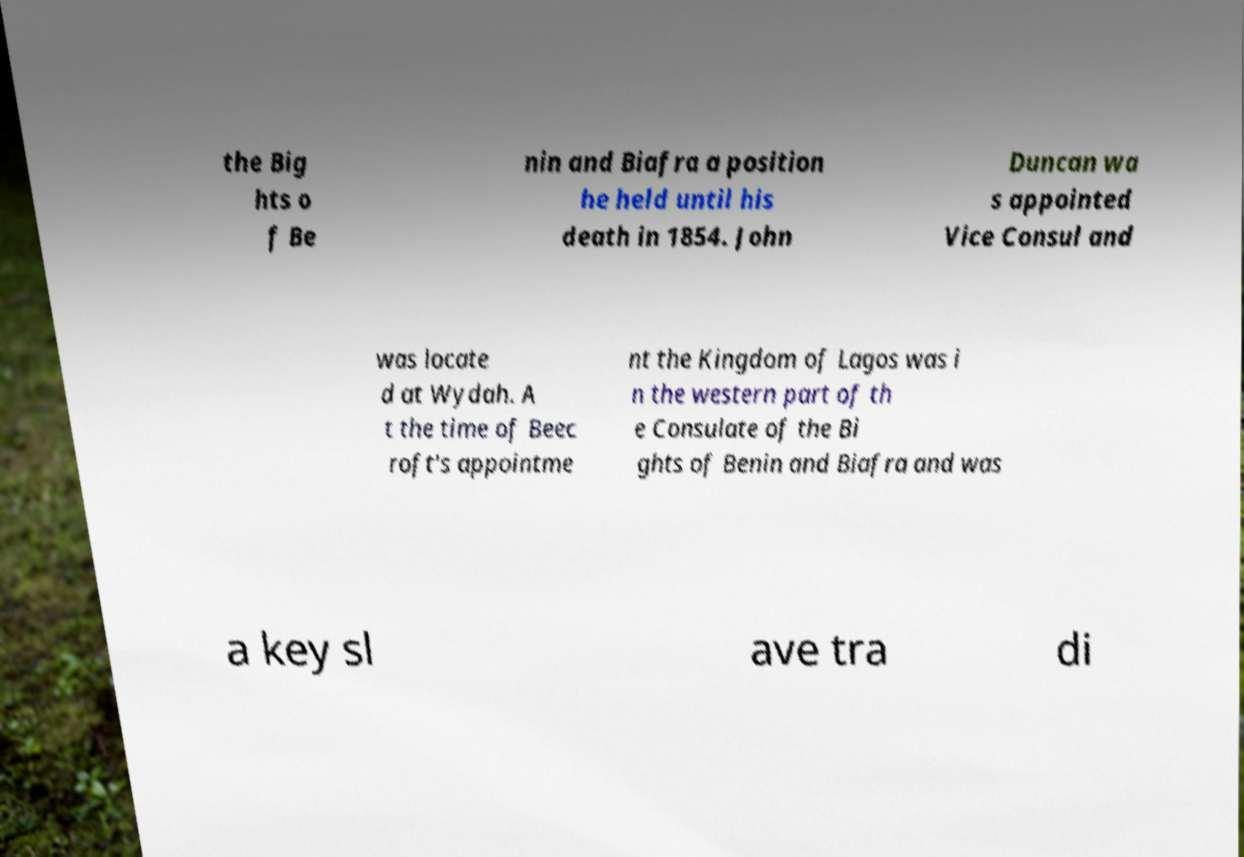I need the written content from this picture converted into text. Can you do that? the Big hts o f Be nin and Biafra a position he held until his death in 1854. John Duncan wa s appointed Vice Consul and was locate d at Wydah. A t the time of Beec roft's appointme nt the Kingdom of Lagos was i n the western part of th e Consulate of the Bi ghts of Benin and Biafra and was a key sl ave tra di 